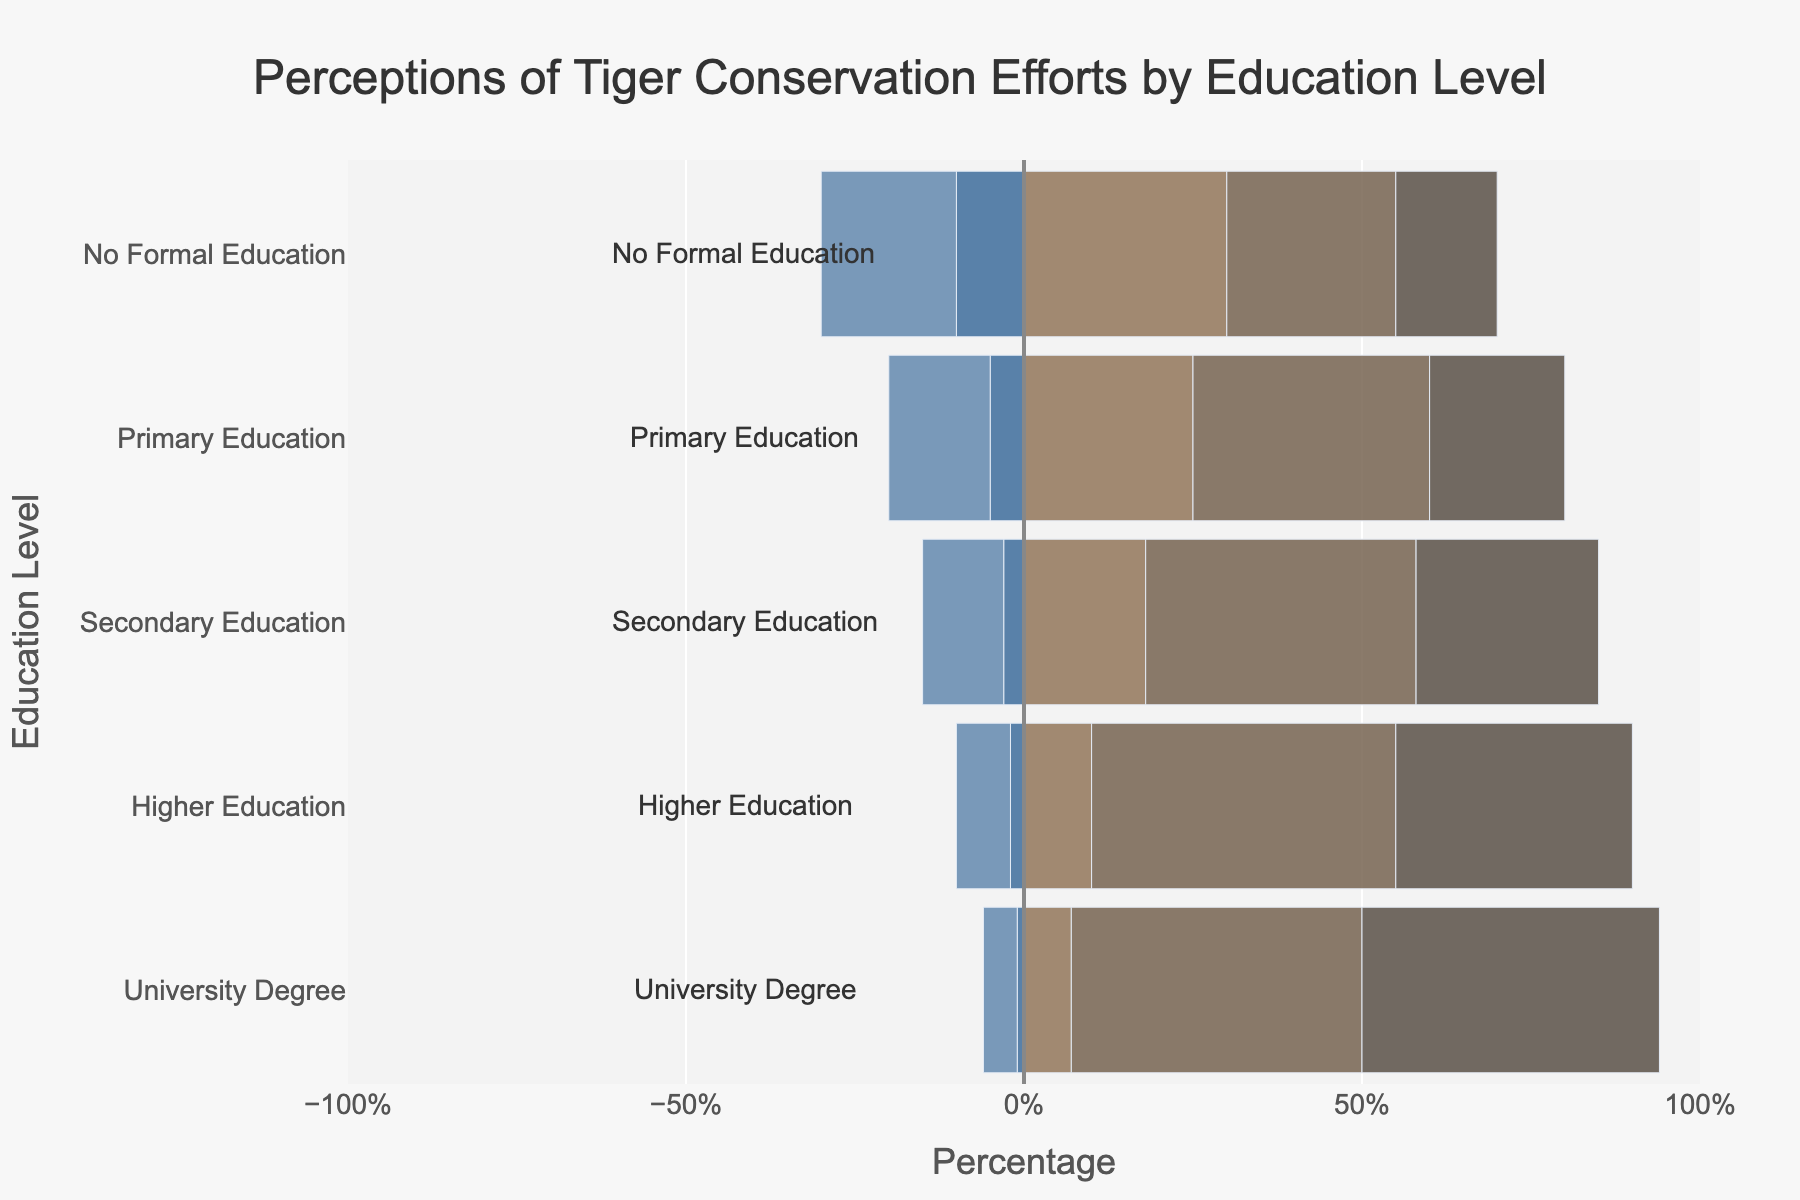Which education level group shows the highest approval (Approve and Strongly Approve combined) for tiger conservation efforts? To find this, look at the bars for "Approve" and "Strongly Approve" for each education level and add their values. The highest is the one with the largest total. University Degree has (43 + 44) = 87.
Answer: University Degree Which education level has the lowest disapproval (Strongly Disapprove and Disapprove combined) for tiger conservation efforts? Check the bars for "Strongly Disapprove" and "Disapprove" for each education level. Add their values and find the smallest sum. University Degree has (1 + 5) = 6.
Answer: University Degree What is the percentage difference in strong approval (Strongly Approve) between those with no formal education and those with a university degree? The Strongly Approve bar for No Formal Education is 15%, and for University Degree is 44%. The difference is calculated as 44% - 15% = 29%.
Answer: 29% Which education level shows the highest neutral perception (Neutral) towards tiger conservation efforts? Compare the lengths of the Neutral bars for all education levels. No Formal Education has 30%, which is the highest.
Answer: No Formal Education Across all education levels, which perception category (Strongly Disapprove, Disapprove, Neutral, Approve, Strongly Approve) generally increases with higher education? Notice the trend of each perception category across increasing education levels. Both Approve and Strongly Approve increase with higher education.
Answer: Approve and Strongly Approve For primary education, what is the combined percentage of disapproval (Strongly Disapprove and Disapprove) and approval (Approve and Strongly Approve)? Sum the percentages of Strongly Disapprove and Disapprove for Primary Education, which are (5% + 15%) = 20%. Then sum the percentages for Approve and Strongly Approve, which are (35% + 20%) = 55%. Combined, they are 20% + 55% = 75%.
Answer: 75% Compare the percentage of people with a secondary education who strongly approve of tiger conservation efforts with those who only approve. Which is greater and by how much? Look at Secondary Education bars for Approve and Strongly Approve. Approve is 40% and Strongly Approve is 27%. The difference is 40% - 27% = 13%. Approve is greater by 13%.
Answer: Approve by 13% How does the percentage of those with higher education who are neutral compare to those with primary education who are neutral? The Neutral bars show 10% for Higher Education and 25% for Primary Education. Noticing the difference is 25% - 10% = 15%.
Answer: Primary Education is 15% higher What is the average percentage of approval (Approve and Strongly Approve combined) across all education levels? Sum the percentages of Approve and Strongly Approve for each education level (25+15, 35+20, 40+27, 45+35, 43+44), then divide by the number of education levels (5). The sum is 40, 55, 67, 80, 87, with a total of 329. Average is 329/5 = 65.8%.
Answer: 65.8% What trend do you notice in the perception of tiger conservation efforts as the education level increases from no formal education to a university degree? Notice that with increasing education levels, the percentages of Approve and Strongly Approve generally increase, while Strongly Disapprove and Disapprove decrease. This indicates higher education tends to have greater approval of tiger conservation efforts.
Answer: Increasing approval with higher education 